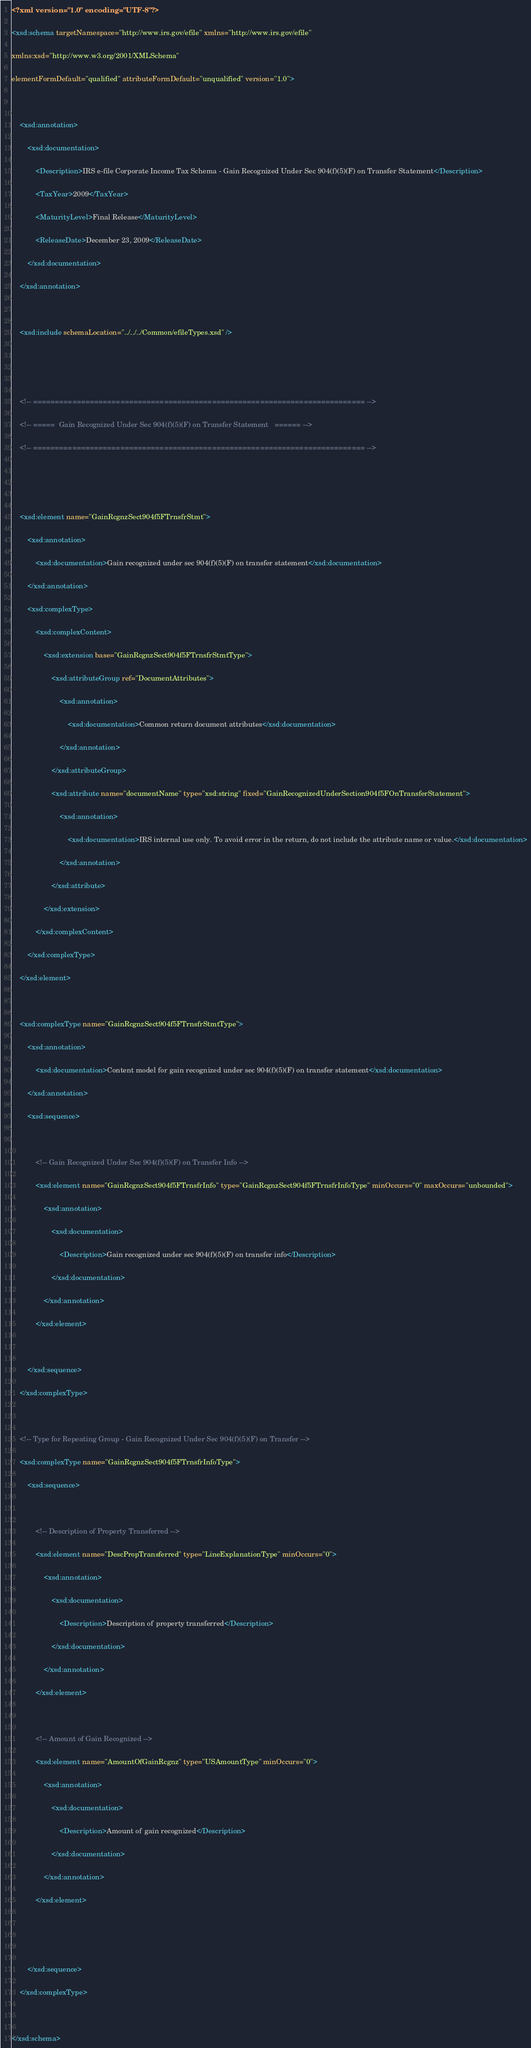<code> <loc_0><loc_0><loc_500><loc_500><_XML_><?xml version="1.0" encoding="UTF-8"?>
<xsd:schema targetNamespace="http://www.irs.gov/efile" xmlns="http://www.irs.gov/efile"
xmlns:xsd="http://www.w3.org/2001/XMLSchema"
elementFormDefault="qualified" attributeFormDefault="unqualified" version="1.0">

	<xsd:annotation>
		<xsd:documentation>
			<Description>IRS e-file Corporate Income Tax Schema - Gain Recognized Under Sec 904(f)(5)(F) on Transfer Statement</Description>
			<TaxYear>2009</TaxYear>
			<MaturityLevel>Final Release</MaturityLevel>
			<ReleaseDate>December 23, 2009</ReleaseDate>
		</xsd:documentation>
	</xsd:annotation>

	<xsd:include schemaLocation="../../../Common/efileTypes.xsd" />


	<!-- ============================================================================ -->
	<!-- =====  Gain Recognized Under Sec 904(f)(5)(F) on Transfer Statement   ====== -->
	<!-- ============================================================================ -->


	<xsd:element name="GainRcgnzSect904f5FTrnsfrStmt">
		<xsd:annotation>
			<xsd:documentation>Gain recognized under sec 904(f)(5)(F) on transfer statement</xsd:documentation>
		</xsd:annotation>
		<xsd:complexType>
			<xsd:complexContent>
				<xsd:extension base="GainRcgnzSect904f5FTrnsfrStmtType">
					<xsd:attributeGroup ref="DocumentAttributes">
						<xsd:annotation>
							<xsd:documentation>Common return document attributes</xsd:documentation>
						</xsd:annotation>
					</xsd:attributeGroup>
					<xsd:attribute name="documentName" type="xsd:string" fixed="GainRecognizedUnderSection904f5FOnTransferStatement">
						<xsd:annotation>
							<xsd:documentation>IRS internal use only. To avoid error in the return, do not include the attribute name or value.</xsd:documentation>
						</xsd:annotation>
					</xsd:attribute>
				</xsd:extension>
			</xsd:complexContent>
		</xsd:complexType>
	</xsd:element>

	<xsd:complexType name="GainRcgnzSect904f5FTrnsfrStmtType">
		<xsd:annotation>
			<xsd:documentation>Content model for gain recognized under sec 904(f)(5)(F) on transfer statement</xsd:documentation>
		</xsd:annotation>
		<xsd:sequence>

			<!-- Gain Recognized Under Sec 904(f)(5)(F) on Transfer Info -->
			<xsd:element name="GainRcgnzSect904f5FTrnsfrInfo" type="GainRcgnzSect904f5FTrnsfrInfoType" minOccurs="0" maxOccurs="unbounded">
				<xsd:annotation>
					<xsd:documentation>
						<Description>Gain recognized under sec 904(f)(5)(F) on transfer info</Description>
					</xsd:documentation>
				</xsd:annotation>
			</xsd:element>

		</xsd:sequence>
	</xsd:complexType>

	<!-- Type for Repeating Group - Gain Recognized Under Sec 904(f)(5)(F) on Transfer -->
	<xsd:complexType name="GainRcgnzSect904f5FTrnsfrInfoType">
		<xsd:sequence>

			<!-- Description of Property Transferred -->
			<xsd:element name="DescPropTransferred" type="LineExplanationType" minOccurs="0">
				<xsd:annotation>
					<xsd:documentation>
						<Description>Description of property transferred</Description>
					</xsd:documentation>
				</xsd:annotation>
			</xsd:element>

			<!-- Amount of Gain Recognized -->
			<xsd:element name="AmountOfGainRcgnz" type="USAmountType" minOccurs="0">
				<xsd:annotation>
					<xsd:documentation>
						<Description>Amount of gain recognized</Description>
					</xsd:documentation>
				</xsd:annotation>
			</xsd:element>


		</xsd:sequence>
	</xsd:complexType>

</xsd:schema>
</code> 